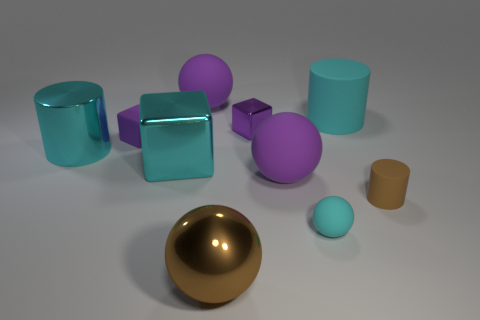There is a big purple sphere that is in front of the big cylinder on the right side of the tiny cyan matte object; what is it made of?
Give a very brief answer. Rubber. Is the shape of the brown thing that is in front of the brown matte thing the same as  the small cyan matte thing?
Give a very brief answer. Yes. What is the color of the small cylinder that is made of the same material as the cyan sphere?
Your answer should be compact. Brown. What material is the cyan thing that is behind the metal cylinder?
Give a very brief answer. Rubber. There is a big brown object; is it the same shape as the cyan thing behind the cyan metal cylinder?
Your response must be concise. No. What is the material of the small object that is on the right side of the purple metallic block and on the left side of the large rubber cylinder?
Make the answer very short. Rubber. There is a ball that is the same size as the brown rubber cylinder; what color is it?
Keep it short and to the point. Cyan. Do the small sphere and the small purple block to the left of the large brown shiny sphere have the same material?
Provide a short and direct response. Yes. What number of other things are the same size as the brown shiny object?
Provide a short and direct response. 5. Is there a cyan block to the right of the large purple object in front of the big rubber thing left of the brown shiny thing?
Give a very brief answer. No. 